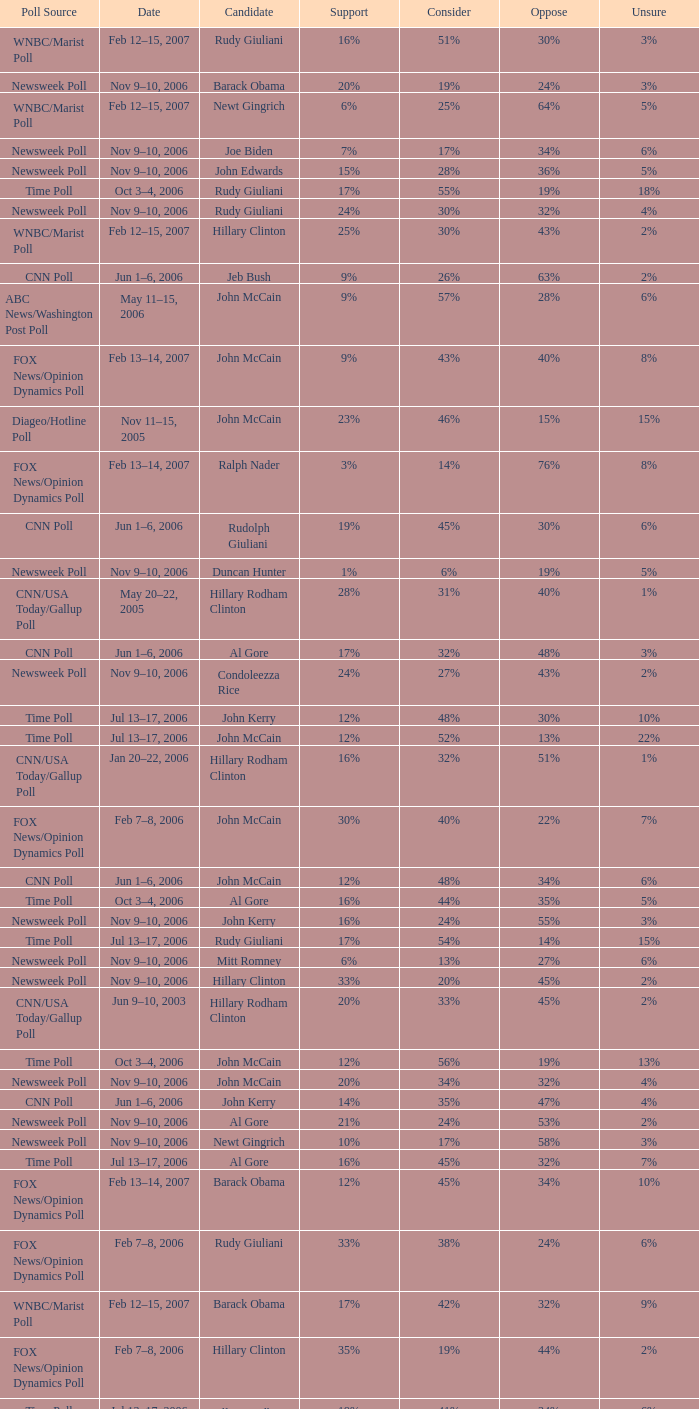What percentage of people were opposed to the candidate based on the Time Poll poll that showed 6% of people were unsure? 34%. 